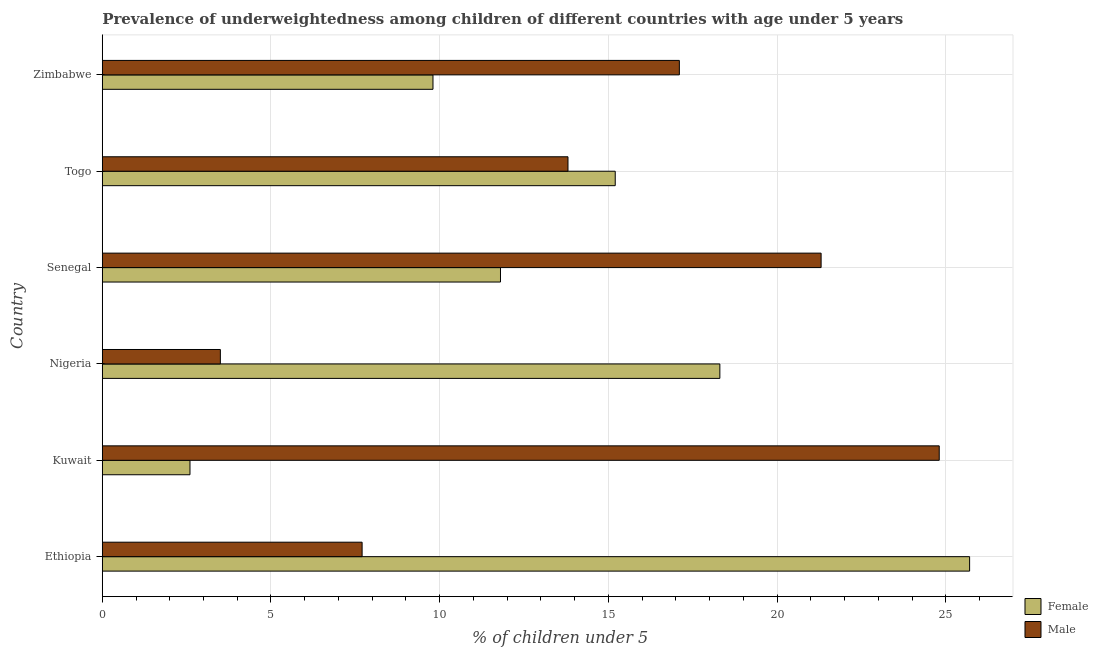How many different coloured bars are there?
Offer a terse response. 2. Are the number of bars per tick equal to the number of legend labels?
Provide a short and direct response. Yes. How many bars are there on the 6th tick from the top?
Provide a short and direct response. 2. How many bars are there on the 1st tick from the bottom?
Your answer should be compact. 2. What is the label of the 2nd group of bars from the top?
Give a very brief answer. Togo. What is the percentage of underweighted male children in Zimbabwe?
Your response must be concise. 17.1. Across all countries, what is the maximum percentage of underweighted female children?
Give a very brief answer. 25.7. Across all countries, what is the minimum percentage of underweighted female children?
Give a very brief answer. 2.6. In which country was the percentage of underweighted male children maximum?
Provide a short and direct response. Kuwait. In which country was the percentage of underweighted female children minimum?
Your response must be concise. Kuwait. What is the total percentage of underweighted male children in the graph?
Your answer should be very brief. 88.2. What is the difference between the percentage of underweighted male children in Ethiopia and that in Togo?
Offer a terse response. -6.1. What is the difference between the percentage of underweighted male children in Togo and the percentage of underweighted female children in Nigeria?
Give a very brief answer. -4.5. What is the average percentage of underweighted male children per country?
Keep it short and to the point. 14.7. What is the ratio of the percentage of underweighted male children in Kuwait to that in Togo?
Your response must be concise. 1.8. Is the percentage of underweighted female children in Togo less than that in Zimbabwe?
Offer a very short reply. No. Is the difference between the percentage of underweighted female children in Togo and Zimbabwe greater than the difference between the percentage of underweighted male children in Togo and Zimbabwe?
Keep it short and to the point. Yes. What is the difference between the highest and the second highest percentage of underweighted male children?
Provide a short and direct response. 3.5. What is the difference between the highest and the lowest percentage of underweighted male children?
Keep it short and to the point. 21.3. What does the 1st bar from the top in Senegal represents?
Offer a very short reply. Male. What does the 1st bar from the bottom in Zimbabwe represents?
Give a very brief answer. Female. Does the graph contain any zero values?
Provide a short and direct response. No. Where does the legend appear in the graph?
Give a very brief answer. Bottom right. How are the legend labels stacked?
Make the answer very short. Vertical. What is the title of the graph?
Keep it short and to the point. Prevalence of underweightedness among children of different countries with age under 5 years. Does "Savings" appear as one of the legend labels in the graph?
Offer a very short reply. No. What is the label or title of the X-axis?
Your answer should be compact.  % of children under 5. What is the  % of children under 5 of Female in Ethiopia?
Your answer should be very brief. 25.7. What is the  % of children under 5 in Male in Ethiopia?
Your response must be concise. 7.7. What is the  % of children under 5 in Female in Kuwait?
Your answer should be compact. 2.6. What is the  % of children under 5 in Male in Kuwait?
Your response must be concise. 24.8. What is the  % of children under 5 in Female in Nigeria?
Offer a very short reply. 18.3. What is the  % of children under 5 of Female in Senegal?
Offer a very short reply. 11.8. What is the  % of children under 5 of Male in Senegal?
Offer a very short reply. 21.3. What is the  % of children under 5 in Female in Togo?
Keep it short and to the point. 15.2. What is the  % of children under 5 of Male in Togo?
Provide a short and direct response. 13.8. What is the  % of children under 5 in Female in Zimbabwe?
Provide a short and direct response. 9.8. What is the  % of children under 5 of Male in Zimbabwe?
Offer a very short reply. 17.1. Across all countries, what is the maximum  % of children under 5 of Female?
Your response must be concise. 25.7. Across all countries, what is the maximum  % of children under 5 in Male?
Provide a short and direct response. 24.8. Across all countries, what is the minimum  % of children under 5 of Female?
Your answer should be very brief. 2.6. What is the total  % of children under 5 in Female in the graph?
Keep it short and to the point. 83.4. What is the total  % of children under 5 in Male in the graph?
Offer a terse response. 88.2. What is the difference between the  % of children under 5 in Female in Ethiopia and that in Kuwait?
Give a very brief answer. 23.1. What is the difference between the  % of children under 5 in Male in Ethiopia and that in Kuwait?
Offer a terse response. -17.1. What is the difference between the  % of children under 5 of Male in Ethiopia and that in Nigeria?
Your answer should be very brief. 4.2. What is the difference between the  % of children under 5 of Male in Ethiopia and that in Senegal?
Provide a short and direct response. -13.6. What is the difference between the  % of children under 5 of Female in Ethiopia and that in Togo?
Provide a succinct answer. 10.5. What is the difference between the  % of children under 5 in Female in Ethiopia and that in Zimbabwe?
Keep it short and to the point. 15.9. What is the difference between the  % of children under 5 in Male in Ethiopia and that in Zimbabwe?
Ensure brevity in your answer.  -9.4. What is the difference between the  % of children under 5 in Female in Kuwait and that in Nigeria?
Offer a very short reply. -15.7. What is the difference between the  % of children under 5 of Male in Kuwait and that in Nigeria?
Your answer should be compact. 21.3. What is the difference between the  % of children under 5 of Female in Kuwait and that in Senegal?
Give a very brief answer. -9.2. What is the difference between the  % of children under 5 in Female in Kuwait and that in Togo?
Offer a very short reply. -12.6. What is the difference between the  % of children under 5 in Male in Kuwait and that in Togo?
Provide a succinct answer. 11. What is the difference between the  % of children under 5 in Female in Kuwait and that in Zimbabwe?
Give a very brief answer. -7.2. What is the difference between the  % of children under 5 in Male in Nigeria and that in Senegal?
Ensure brevity in your answer.  -17.8. What is the difference between the  % of children under 5 in Male in Nigeria and that in Togo?
Ensure brevity in your answer.  -10.3. What is the difference between the  % of children under 5 in Female in Nigeria and that in Zimbabwe?
Your answer should be compact. 8.5. What is the difference between the  % of children under 5 in Male in Nigeria and that in Zimbabwe?
Provide a succinct answer. -13.6. What is the difference between the  % of children under 5 of Female in Senegal and that in Togo?
Offer a very short reply. -3.4. What is the difference between the  % of children under 5 in Male in Senegal and that in Zimbabwe?
Make the answer very short. 4.2. What is the difference between the  % of children under 5 of Female in Togo and that in Zimbabwe?
Provide a short and direct response. 5.4. What is the difference between the  % of children under 5 of Male in Togo and that in Zimbabwe?
Your answer should be compact. -3.3. What is the difference between the  % of children under 5 in Female in Ethiopia and the  % of children under 5 in Male in Kuwait?
Make the answer very short. 0.9. What is the difference between the  % of children under 5 of Female in Ethiopia and the  % of children under 5 of Male in Nigeria?
Make the answer very short. 22.2. What is the difference between the  % of children under 5 of Female in Ethiopia and the  % of children under 5 of Male in Senegal?
Offer a very short reply. 4.4. What is the difference between the  % of children under 5 in Female in Ethiopia and the  % of children under 5 in Male in Zimbabwe?
Offer a terse response. 8.6. What is the difference between the  % of children under 5 of Female in Kuwait and the  % of children under 5 of Male in Senegal?
Make the answer very short. -18.7. What is the difference between the  % of children under 5 in Female in Kuwait and the  % of children under 5 in Male in Zimbabwe?
Your answer should be compact. -14.5. What is the difference between the  % of children under 5 of Female in Nigeria and the  % of children under 5 of Male in Senegal?
Your answer should be very brief. -3. What is the difference between the  % of children under 5 of Female in Nigeria and the  % of children under 5 of Male in Togo?
Make the answer very short. 4.5. What is the difference between the  % of children under 5 of Female in Nigeria and the  % of children under 5 of Male in Zimbabwe?
Your response must be concise. 1.2. What is the difference between the  % of children under 5 in Female in Senegal and the  % of children under 5 in Male in Togo?
Give a very brief answer. -2. What is the difference between the  % of children under 5 in Female in Senegal and the  % of children under 5 in Male in Zimbabwe?
Ensure brevity in your answer.  -5.3. What is the average  % of children under 5 of Female per country?
Make the answer very short. 13.9. What is the difference between the  % of children under 5 in Female and  % of children under 5 in Male in Ethiopia?
Keep it short and to the point. 18. What is the difference between the  % of children under 5 in Female and  % of children under 5 in Male in Kuwait?
Offer a very short reply. -22.2. What is the ratio of the  % of children under 5 of Female in Ethiopia to that in Kuwait?
Your answer should be very brief. 9.88. What is the ratio of the  % of children under 5 in Male in Ethiopia to that in Kuwait?
Your response must be concise. 0.31. What is the ratio of the  % of children under 5 in Female in Ethiopia to that in Nigeria?
Provide a short and direct response. 1.4. What is the ratio of the  % of children under 5 of Male in Ethiopia to that in Nigeria?
Provide a short and direct response. 2.2. What is the ratio of the  % of children under 5 in Female in Ethiopia to that in Senegal?
Make the answer very short. 2.18. What is the ratio of the  % of children under 5 of Male in Ethiopia to that in Senegal?
Your answer should be very brief. 0.36. What is the ratio of the  % of children under 5 in Female in Ethiopia to that in Togo?
Keep it short and to the point. 1.69. What is the ratio of the  % of children under 5 of Male in Ethiopia to that in Togo?
Offer a terse response. 0.56. What is the ratio of the  % of children under 5 of Female in Ethiopia to that in Zimbabwe?
Ensure brevity in your answer.  2.62. What is the ratio of the  % of children under 5 of Male in Ethiopia to that in Zimbabwe?
Ensure brevity in your answer.  0.45. What is the ratio of the  % of children under 5 of Female in Kuwait to that in Nigeria?
Offer a very short reply. 0.14. What is the ratio of the  % of children under 5 in Male in Kuwait to that in Nigeria?
Your answer should be compact. 7.09. What is the ratio of the  % of children under 5 of Female in Kuwait to that in Senegal?
Provide a short and direct response. 0.22. What is the ratio of the  % of children under 5 in Male in Kuwait to that in Senegal?
Your response must be concise. 1.16. What is the ratio of the  % of children under 5 in Female in Kuwait to that in Togo?
Provide a succinct answer. 0.17. What is the ratio of the  % of children under 5 of Male in Kuwait to that in Togo?
Offer a very short reply. 1.8. What is the ratio of the  % of children under 5 of Female in Kuwait to that in Zimbabwe?
Your response must be concise. 0.27. What is the ratio of the  % of children under 5 in Male in Kuwait to that in Zimbabwe?
Provide a succinct answer. 1.45. What is the ratio of the  % of children under 5 in Female in Nigeria to that in Senegal?
Offer a very short reply. 1.55. What is the ratio of the  % of children under 5 of Male in Nigeria to that in Senegal?
Your answer should be compact. 0.16. What is the ratio of the  % of children under 5 in Female in Nigeria to that in Togo?
Offer a terse response. 1.2. What is the ratio of the  % of children under 5 in Male in Nigeria to that in Togo?
Your response must be concise. 0.25. What is the ratio of the  % of children under 5 of Female in Nigeria to that in Zimbabwe?
Your response must be concise. 1.87. What is the ratio of the  % of children under 5 of Male in Nigeria to that in Zimbabwe?
Provide a succinct answer. 0.2. What is the ratio of the  % of children under 5 in Female in Senegal to that in Togo?
Offer a very short reply. 0.78. What is the ratio of the  % of children under 5 in Male in Senegal to that in Togo?
Make the answer very short. 1.54. What is the ratio of the  % of children under 5 in Female in Senegal to that in Zimbabwe?
Provide a succinct answer. 1.2. What is the ratio of the  % of children under 5 of Male in Senegal to that in Zimbabwe?
Give a very brief answer. 1.25. What is the ratio of the  % of children under 5 of Female in Togo to that in Zimbabwe?
Make the answer very short. 1.55. What is the ratio of the  % of children under 5 of Male in Togo to that in Zimbabwe?
Your answer should be compact. 0.81. What is the difference between the highest and the second highest  % of children under 5 in Female?
Provide a succinct answer. 7.4. What is the difference between the highest and the lowest  % of children under 5 in Female?
Your response must be concise. 23.1. What is the difference between the highest and the lowest  % of children under 5 in Male?
Your answer should be compact. 21.3. 